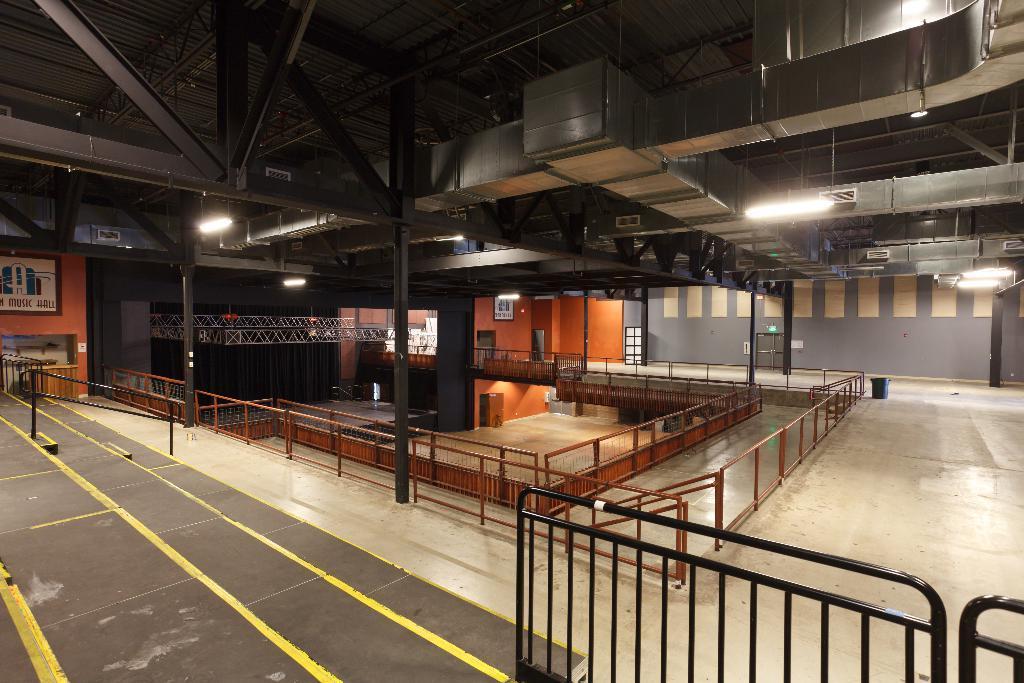Please provide a concise description of this image. This image is clicked inside a room. There are railings in the room. To the right there is a dustbin on the floor. There are picture frames hanging on the wall. There are lights to the ceiling. 